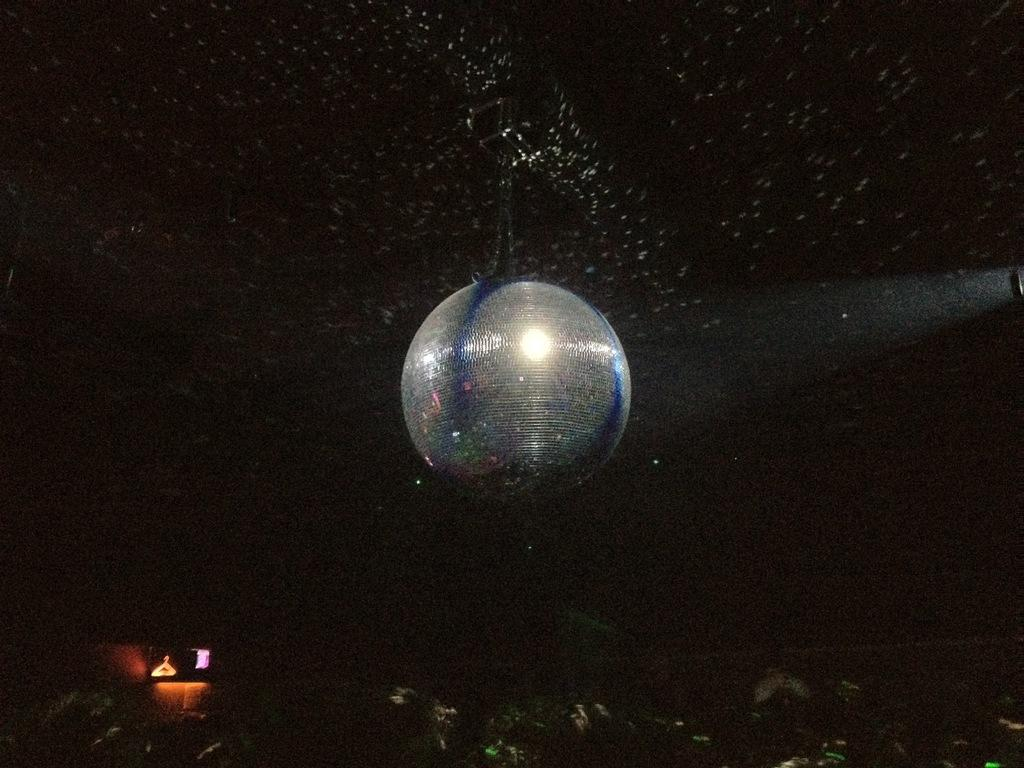What is hanging in the image? There is an object hanging in the image. How would you describe the shape of the hanging object? The object resembles a sphere. What can be observed about the background of the image? The background of the image is dark. What type of glass can be seen in the image? There is no glass present in the image. Can you tell me how many fangs are visible on the hanging object? The hanging object does not have any fangs, as it resembles a sphere. What language is spoken by the hanging object in the image? The hanging object is an inanimate object and does not speak any language. 